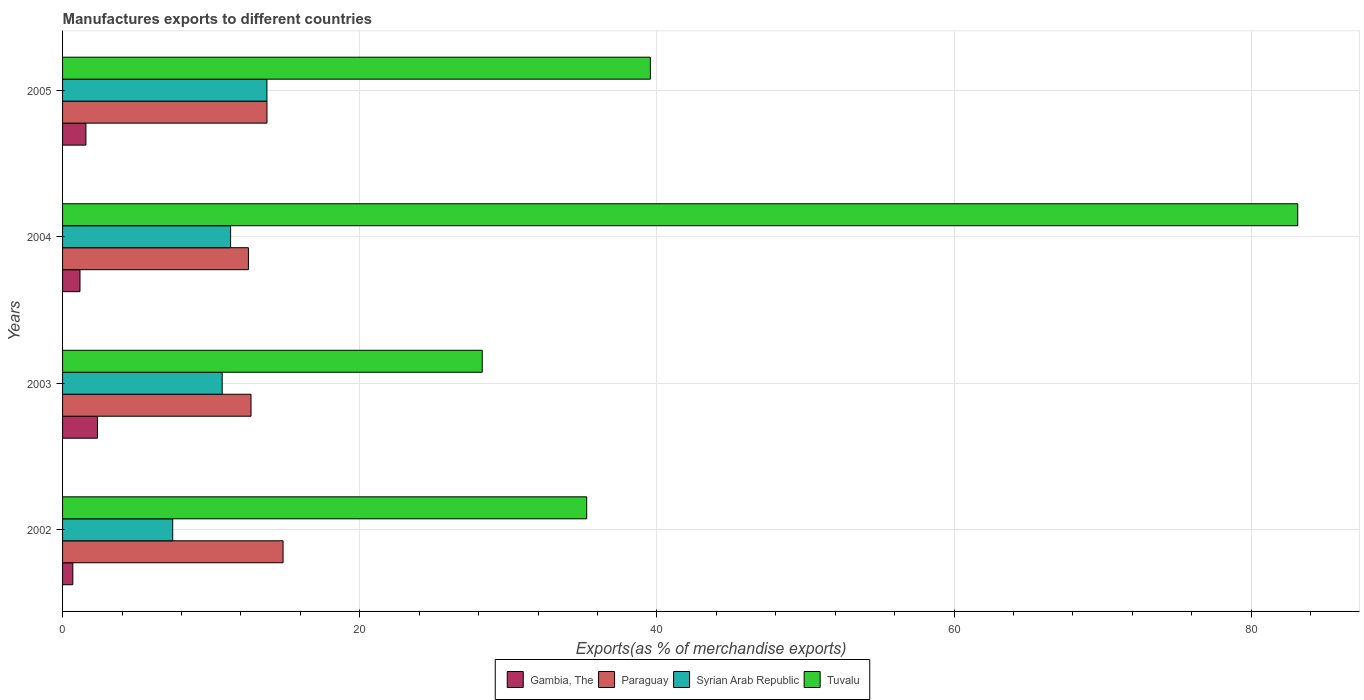How many groups of bars are there?
Your response must be concise. 4. Are the number of bars on each tick of the Y-axis equal?
Ensure brevity in your answer.  Yes. How many bars are there on the 4th tick from the top?
Your answer should be compact. 4. How many bars are there on the 3rd tick from the bottom?
Make the answer very short. 4. What is the label of the 3rd group of bars from the top?
Provide a succinct answer. 2003. What is the percentage of exports to different countries in Paraguay in 2004?
Keep it short and to the point. 12.51. Across all years, what is the maximum percentage of exports to different countries in Gambia, The?
Your answer should be compact. 2.35. Across all years, what is the minimum percentage of exports to different countries in Gambia, The?
Make the answer very short. 0.69. In which year was the percentage of exports to different countries in Syrian Arab Republic maximum?
Keep it short and to the point. 2005. What is the total percentage of exports to different countries in Paraguay in the graph?
Your response must be concise. 53.79. What is the difference between the percentage of exports to different countries in Tuvalu in 2003 and that in 2005?
Give a very brief answer. -11.32. What is the difference between the percentage of exports to different countries in Syrian Arab Republic in 2003 and the percentage of exports to different countries in Gambia, The in 2002?
Make the answer very short. 10.05. What is the average percentage of exports to different countries in Syrian Arab Republic per year?
Provide a short and direct response. 10.8. In the year 2003, what is the difference between the percentage of exports to different countries in Gambia, The and percentage of exports to different countries in Tuvalu?
Offer a very short reply. -25.9. In how many years, is the percentage of exports to different countries in Paraguay greater than 48 %?
Ensure brevity in your answer.  0. What is the ratio of the percentage of exports to different countries in Paraguay in 2004 to that in 2005?
Your answer should be very brief. 0.91. What is the difference between the highest and the second highest percentage of exports to different countries in Syrian Arab Republic?
Your response must be concise. 2.44. What is the difference between the highest and the lowest percentage of exports to different countries in Paraguay?
Provide a succinct answer. 2.33. In how many years, is the percentage of exports to different countries in Tuvalu greater than the average percentage of exports to different countries in Tuvalu taken over all years?
Your response must be concise. 1. Is the sum of the percentage of exports to different countries in Syrian Arab Republic in 2003 and 2004 greater than the maximum percentage of exports to different countries in Paraguay across all years?
Your response must be concise. Yes. What does the 2nd bar from the top in 2004 represents?
Offer a very short reply. Syrian Arab Republic. What does the 2nd bar from the bottom in 2002 represents?
Provide a short and direct response. Paraguay. How many bars are there?
Your response must be concise. 16. Does the graph contain any zero values?
Offer a terse response. No. Where does the legend appear in the graph?
Provide a succinct answer. Bottom center. How many legend labels are there?
Keep it short and to the point. 4. What is the title of the graph?
Your answer should be compact. Manufactures exports to different countries. Does "East Asia (all income levels)" appear as one of the legend labels in the graph?
Make the answer very short. No. What is the label or title of the X-axis?
Ensure brevity in your answer.  Exports(as % of merchandise exports). What is the label or title of the Y-axis?
Provide a succinct answer. Years. What is the Exports(as % of merchandise exports) in Gambia, The in 2002?
Provide a short and direct response. 0.69. What is the Exports(as % of merchandise exports) of Paraguay in 2002?
Offer a terse response. 14.84. What is the Exports(as % of merchandise exports) in Syrian Arab Republic in 2002?
Offer a very short reply. 7.41. What is the Exports(as % of merchandise exports) in Tuvalu in 2002?
Your answer should be very brief. 35.28. What is the Exports(as % of merchandise exports) of Gambia, The in 2003?
Offer a terse response. 2.35. What is the Exports(as % of merchandise exports) of Paraguay in 2003?
Your answer should be compact. 12.68. What is the Exports(as % of merchandise exports) in Syrian Arab Republic in 2003?
Offer a very short reply. 10.74. What is the Exports(as % of merchandise exports) in Tuvalu in 2003?
Your answer should be compact. 28.25. What is the Exports(as % of merchandise exports) in Gambia, The in 2004?
Ensure brevity in your answer.  1.17. What is the Exports(as % of merchandise exports) of Paraguay in 2004?
Offer a terse response. 12.51. What is the Exports(as % of merchandise exports) of Syrian Arab Republic in 2004?
Keep it short and to the point. 11.31. What is the Exports(as % of merchandise exports) in Tuvalu in 2004?
Make the answer very short. 83.13. What is the Exports(as % of merchandise exports) of Gambia, The in 2005?
Make the answer very short. 1.57. What is the Exports(as % of merchandise exports) of Paraguay in 2005?
Your answer should be very brief. 13.76. What is the Exports(as % of merchandise exports) in Syrian Arab Republic in 2005?
Your answer should be very brief. 13.75. What is the Exports(as % of merchandise exports) in Tuvalu in 2005?
Ensure brevity in your answer.  39.56. Across all years, what is the maximum Exports(as % of merchandise exports) in Gambia, The?
Offer a terse response. 2.35. Across all years, what is the maximum Exports(as % of merchandise exports) of Paraguay?
Give a very brief answer. 14.84. Across all years, what is the maximum Exports(as % of merchandise exports) in Syrian Arab Republic?
Your answer should be very brief. 13.75. Across all years, what is the maximum Exports(as % of merchandise exports) of Tuvalu?
Your answer should be compact. 83.13. Across all years, what is the minimum Exports(as % of merchandise exports) in Gambia, The?
Give a very brief answer. 0.69. Across all years, what is the minimum Exports(as % of merchandise exports) in Paraguay?
Offer a terse response. 12.51. Across all years, what is the minimum Exports(as % of merchandise exports) in Syrian Arab Republic?
Provide a succinct answer. 7.41. Across all years, what is the minimum Exports(as % of merchandise exports) of Tuvalu?
Provide a short and direct response. 28.25. What is the total Exports(as % of merchandise exports) of Gambia, The in the graph?
Make the answer very short. 5.79. What is the total Exports(as % of merchandise exports) in Paraguay in the graph?
Keep it short and to the point. 53.79. What is the total Exports(as % of merchandise exports) of Syrian Arab Republic in the graph?
Provide a succinct answer. 43.22. What is the total Exports(as % of merchandise exports) in Tuvalu in the graph?
Make the answer very short. 186.22. What is the difference between the Exports(as % of merchandise exports) in Gambia, The in 2002 and that in 2003?
Provide a succinct answer. -1.66. What is the difference between the Exports(as % of merchandise exports) in Paraguay in 2002 and that in 2003?
Offer a very short reply. 2.16. What is the difference between the Exports(as % of merchandise exports) in Syrian Arab Republic in 2002 and that in 2003?
Offer a terse response. -3.33. What is the difference between the Exports(as % of merchandise exports) in Tuvalu in 2002 and that in 2003?
Make the answer very short. 7.03. What is the difference between the Exports(as % of merchandise exports) of Gambia, The in 2002 and that in 2004?
Your answer should be very brief. -0.48. What is the difference between the Exports(as % of merchandise exports) of Paraguay in 2002 and that in 2004?
Your response must be concise. 2.33. What is the difference between the Exports(as % of merchandise exports) in Syrian Arab Republic in 2002 and that in 2004?
Provide a succinct answer. -3.9. What is the difference between the Exports(as % of merchandise exports) in Tuvalu in 2002 and that in 2004?
Provide a succinct answer. -47.86. What is the difference between the Exports(as % of merchandise exports) of Gambia, The in 2002 and that in 2005?
Your answer should be compact. -0.88. What is the difference between the Exports(as % of merchandise exports) in Paraguay in 2002 and that in 2005?
Offer a terse response. 1.08. What is the difference between the Exports(as % of merchandise exports) of Syrian Arab Republic in 2002 and that in 2005?
Give a very brief answer. -6.34. What is the difference between the Exports(as % of merchandise exports) in Tuvalu in 2002 and that in 2005?
Your response must be concise. -4.29. What is the difference between the Exports(as % of merchandise exports) of Gambia, The in 2003 and that in 2004?
Provide a short and direct response. 1.18. What is the difference between the Exports(as % of merchandise exports) of Paraguay in 2003 and that in 2004?
Give a very brief answer. 0.17. What is the difference between the Exports(as % of merchandise exports) of Syrian Arab Republic in 2003 and that in 2004?
Provide a short and direct response. -0.57. What is the difference between the Exports(as % of merchandise exports) of Tuvalu in 2003 and that in 2004?
Ensure brevity in your answer.  -54.89. What is the difference between the Exports(as % of merchandise exports) of Gambia, The in 2003 and that in 2005?
Your answer should be very brief. 0.78. What is the difference between the Exports(as % of merchandise exports) in Paraguay in 2003 and that in 2005?
Make the answer very short. -1.07. What is the difference between the Exports(as % of merchandise exports) in Syrian Arab Republic in 2003 and that in 2005?
Your answer should be very brief. -3.01. What is the difference between the Exports(as % of merchandise exports) in Tuvalu in 2003 and that in 2005?
Provide a short and direct response. -11.32. What is the difference between the Exports(as % of merchandise exports) in Gambia, The in 2004 and that in 2005?
Provide a short and direct response. -0.4. What is the difference between the Exports(as % of merchandise exports) of Paraguay in 2004 and that in 2005?
Make the answer very short. -1.25. What is the difference between the Exports(as % of merchandise exports) of Syrian Arab Republic in 2004 and that in 2005?
Your answer should be very brief. -2.44. What is the difference between the Exports(as % of merchandise exports) of Tuvalu in 2004 and that in 2005?
Make the answer very short. 43.57. What is the difference between the Exports(as % of merchandise exports) of Gambia, The in 2002 and the Exports(as % of merchandise exports) of Paraguay in 2003?
Provide a short and direct response. -11.99. What is the difference between the Exports(as % of merchandise exports) in Gambia, The in 2002 and the Exports(as % of merchandise exports) in Syrian Arab Republic in 2003?
Provide a succinct answer. -10.05. What is the difference between the Exports(as % of merchandise exports) of Gambia, The in 2002 and the Exports(as % of merchandise exports) of Tuvalu in 2003?
Your answer should be compact. -27.56. What is the difference between the Exports(as % of merchandise exports) of Paraguay in 2002 and the Exports(as % of merchandise exports) of Syrian Arab Republic in 2003?
Provide a succinct answer. 4.1. What is the difference between the Exports(as % of merchandise exports) of Paraguay in 2002 and the Exports(as % of merchandise exports) of Tuvalu in 2003?
Your response must be concise. -13.41. What is the difference between the Exports(as % of merchandise exports) in Syrian Arab Republic in 2002 and the Exports(as % of merchandise exports) in Tuvalu in 2003?
Give a very brief answer. -20.83. What is the difference between the Exports(as % of merchandise exports) of Gambia, The in 2002 and the Exports(as % of merchandise exports) of Paraguay in 2004?
Your answer should be very brief. -11.82. What is the difference between the Exports(as % of merchandise exports) of Gambia, The in 2002 and the Exports(as % of merchandise exports) of Syrian Arab Republic in 2004?
Give a very brief answer. -10.62. What is the difference between the Exports(as % of merchandise exports) in Gambia, The in 2002 and the Exports(as % of merchandise exports) in Tuvalu in 2004?
Provide a short and direct response. -82.44. What is the difference between the Exports(as % of merchandise exports) in Paraguay in 2002 and the Exports(as % of merchandise exports) in Syrian Arab Republic in 2004?
Offer a very short reply. 3.53. What is the difference between the Exports(as % of merchandise exports) in Paraguay in 2002 and the Exports(as % of merchandise exports) in Tuvalu in 2004?
Ensure brevity in your answer.  -68.29. What is the difference between the Exports(as % of merchandise exports) in Syrian Arab Republic in 2002 and the Exports(as % of merchandise exports) in Tuvalu in 2004?
Your response must be concise. -75.72. What is the difference between the Exports(as % of merchandise exports) of Gambia, The in 2002 and the Exports(as % of merchandise exports) of Paraguay in 2005?
Offer a terse response. -13.07. What is the difference between the Exports(as % of merchandise exports) in Gambia, The in 2002 and the Exports(as % of merchandise exports) in Syrian Arab Republic in 2005?
Offer a terse response. -13.06. What is the difference between the Exports(as % of merchandise exports) of Gambia, The in 2002 and the Exports(as % of merchandise exports) of Tuvalu in 2005?
Your answer should be compact. -38.87. What is the difference between the Exports(as % of merchandise exports) in Paraguay in 2002 and the Exports(as % of merchandise exports) in Syrian Arab Republic in 2005?
Give a very brief answer. 1.09. What is the difference between the Exports(as % of merchandise exports) of Paraguay in 2002 and the Exports(as % of merchandise exports) of Tuvalu in 2005?
Keep it short and to the point. -24.72. What is the difference between the Exports(as % of merchandise exports) in Syrian Arab Republic in 2002 and the Exports(as % of merchandise exports) in Tuvalu in 2005?
Give a very brief answer. -32.15. What is the difference between the Exports(as % of merchandise exports) of Gambia, The in 2003 and the Exports(as % of merchandise exports) of Paraguay in 2004?
Your answer should be compact. -10.16. What is the difference between the Exports(as % of merchandise exports) in Gambia, The in 2003 and the Exports(as % of merchandise exports) in Syrian Arab Republic in 2004?
Keep it short and to the point. -8.96. What is the difference between the Exports(as % of merchandise exports) of Gambia, The in 2003 and the Exports(as % of merchandise exports) of Tuvalu in 2004?
Provide a succinct answer. -80.78. What is the difference between the Exports(as % of merchandise exports) in Paraguay in 2003 and the Exports(as % of merchandise exports) in Syrian Arab Republic in 2004?
Offer a very short reply. 1.37. What is the difference between the Exports(as % of merchandise exports) in Paraguay in 2003 and the Exports(as % of merchandise exports) in Tuvalu in 2004?
Your response must be concise. -70.45. What is the difference between the Exports(as % of merchandise exports) in Syrian Arab Republic in 2003 and the Exports(as % of merchandise exports) in Tuvalu in 2004?
Provide a succinct answer. -72.39. What is the difference between the Exports(as % of merchandise exports) of Gambia, The in 2003 and the Exports(as % of merchandise exports) of Paraguay in 2005?
Offer a terse response. -11.41. What is the difference between the Exports(as % of merchandise exports) of Gambia, The in 2003 and the Exports(as % of merchandise exports) of Syrian Arab Republic in 2005?
Make the answer very short. -11.4. What is the difference between the Exports(as % of merchandise exports) of Gambia, The in 2003 and the Exports(as % of merchandise exports) of Tuvalu in 2005?
Offer a very short reply. -37.21. What is the difference between the Exports(as % of merchandise exports) of Paraguay in 2003 and the Exports(as % of merchandise exports) of Syrian Arab Republic in 2005?
Your response must be concise. -1.07. What is the difference between the Exports(as % of merchandise exports) in Paraguay in 2003 and the Exports(as % of merchandise exports) in Tuvalu in 2005?
Provide a short and direct response. -26.88. What is the difference between the Exports(as % of merchandise exports) in Syrian Arab Republic in 2003 and the Exports(as % of merchandise exports) in Tuvalu in 2005?
Offer a very short reply. -28.82. What is the difference between the Exports(as % of merchandise exports) in Gambia, The in 2004 and the Exports(as % of merchandise exports) in Paraguay in 2005?
Give a very brief answer. -12.58. What is the difference between the Exports(as % of merchandise exports) in Gambia, The in 2004 and the Exports(as % of merchandise exports) in Syrian Arab Republic in 2005?
Provide a short and direct response. -12.58. What is the difference between the Exports(as % of merchandise exports) in Gambia, The in 2004 and the Exports(as % of merchandise exports) in Tuvalu in 2005?
Offer a terse response. -38.39. What is the difference between the Exports(as % of merchandise exports) in Paraguay in 2004 and the Exports(as % of merchandise exports) in Syrian Arab Republic in 2005?
Make the answer very short. -1.24. What is the difference between the Exports(as % of merchandise exports) of Paraguay in 2004 and the Exports(as % of merchandise exports) of Tuvalu in 2005?
Your answer should be very brief. -27.05. What is the difference between the Exports(as % of merchandise exports) in Syrian Arab Republic in 2004 and the Exports(as % of merchandise exports) in Tuvalu in 2005?
Keep it short and to the point. -28.25. What is the average Exports(as % of merchandise exports) of Gambia, The per year?
Offer a very short reply. 1.45. What is the average Exports(as % of merchandise exports) of Paraguay per year?
Provide a succinct answer. 13.45. What is the average Exports(as % of merchandise exports) of Syrian Arab Republic per year?
Keep it short and to the point. 10.8. What is the average Exports(as % of merchandise exports) of Tuvalu per year?
Your response must be concise. 46.55. In the year 2002, what is the difference between the Exports(as % of merchandise exports) in Gambia, The and Exports(as % of merchandise exports) in Paraguay?
Your response must be concise. -14.15. In the year 2002, what is the difference between the Exports(as % of merchandise exports) in Gambia, The and Exports(as % of merchandise exports) in Syrian Arab Republic?
Offer a very short reply. -6.72. In the year 2002, what is the difference between the Exports(as % of merchandise exports) in Gambia, The and Exports(as % of merchandise exports) in Tuvalu?
Keep it short and to the point. -34.59. In the year 2002, what is the difference between the Exports(as % of merchandise exports) in Paraguay and Exports(as % of merchandise exports) in Syrian Arab Republic?
Keep it short and to the point. 7.43. In the year 2002, what is the difference between the Exports(as % of merchandise exports) in Paraguay and Exports(as % of merchandise exports) in Tuvalu?
Your response must be concise. -20.44. In the year 2002, what is the difference between the Exports(as % of merchandise exports) of Syrian Arab Republic and Exports(as % of merchandise exports) of Tuvalu?
Ensure brevity in your answer.  -27.86. In the year 2003, what is the difference between the Exports(as % of merchandise exports) in Gambia, The and Exports(as % of merchandise exports) in Paraguay?
Ensure brevity in your answer.  -10.33. In the year 2003, what is the difference between the Exports(as % of merchandise exports) of Gambia, The and Exports(as % of merchandise exports) of Syrian Arab Republic?
Your answer should be very brief. -8.39. In the year 2003, what is the difference between the Exports(as % of merchandise exports) in Gambia, The and Exports(as % of merchandise exports) in Tuvalu?
Ensure brevity in your answer.  -25.9. In the year 2003, what is the difference between the Exports(as % of merchandise exports) in Paraguay and Exports(as % of merchandise exports) in Syrian Arab Republic?
Provide a succinct answer. 1.94. In the year 2003, what is the difference between the Exports(as % of merchandise exports) of Paraguay and Exports(as % of merchandise exports) of Tuvalu?
Offer a terse response. -15.56. In the year 2003, what is the difference between the Exports(as % of merchandise exports) in Syrian Arab Republic and Exports(as % of merchandise exports) in Tuvalu?
Ensure brevity in your answer.  -17.5. In the year 2004, what is the difference between the Exports(as % of merchandise exports) of Gambia, The and Exports(as % of merchandise exports) of Paraguay?
Offer a terse response. -11.34. In the year 2004, what is the difference between the Exports(as % of merchandise exports) in Gambia, The and Exports(as % of merchandise exports) in Syrian Arab Republic?
Give a very brief answer. -10.14. In the year 2004, what is the difference between the Exports(as % of merchandise exports) of Gambia, The and Exports(as % of merchandise exports) of Tuvalu?
Keep it short and to the point. -81.96. In the year 2004, what is the difference between the Exports(as % of merchandise exports) in Paraguay and Exports(as % of merchandise exports) in Syrian Arab Republic?
Keep it short and to the point. 1.2. In the year 2004, what is the difference between the Exports(as % of merchandise exports) in Paraguay and Exports(as % of merchandise exports) in Tuvalu?
Ensure brevity in your answer.  -70.62. In the year 2004, what is the difference between the Exports(as % of merchandise exports) of Syrian Arab Republic and Exports(as % of merchandise exports) of Tuvalu?
Your response must be concise. -71.82. In the year 2005, what is the difference between the Exports(as % of merchandise exports) in Gambia, The and Exports(as % of merchandise exports) in Paraguay?
Provide a short and direct response. -12.19. In the year 2005, what is the difference between the Exports(as % of merchandise exports) of Gambia, The and Exports(as % of merchandise exports) of Syrian Arab Republic?
Your response must be concise. -12.18. In the year 2005, what is the difference between the Exports(as % of merchandise exports) of Gambia, The and Exports(as % of merchandise exports) of Tuvalu?
Offer a terse response. -37.99. In the year 2005, what is the difference between the Exports(as % of merchandise exports) of Paraguay and Exports(as % of merchandise exports) of Syrian Arab Republic?
Give a very brief answer. 0. In the year 2005, what is the difference between the Exports(as % of merchandise exports) of Paraguay and Exports(as % of merchandise exports) of Tuvalu?
Ensure brevity in your answer.  -25.8. In the year 2005, what is the difference between the Exports(as % of merchandise exports) in Syrian Arab Republic and Exports(as % of merchandise exports) in Tuvalu?
Offer a very short reply. -25.81. What is the ratio of the Exports(as % of merchandise exports) in Gambia, The in 2002 to that in 2003?
Your response must be concise. 0.29. What is the ratio of the Exports(as % of merchandise exports) of Paraguay in 2002 to that in 2003?
Make the answer very short. 1.17. What is the ratio of the Exports(as % of merchandise exports) in Syrian Arab Republic in 2002 to that in 2003?
Provide a succinct answer. 0.69. What is the ratio of the Exports(as % of merchandise exports) of Tuvalu in 2002 to that in 2003?
Your answer should be compact. 1.25. What is the ratio of the Exports(as % of merchandise exports) of Gambia, The in 2002 to that in 2004?
Ensure brevity in your answer.  0.59. What is the ratio of the Exports(as % of merchandise exports) of Paraguay in 2002 to that in 2004?
Offer a terse response. 1.19. What is the ratio of the Exports(as % of merchandise exports) in Syrian Arab Republic in 2002 to that in 2004?
Keep it short and to the point. 0.66. What is the ratio of the Exports(as % of merchandise exports) in Tuvalu in 2002 to that in 2004?
Offer a terse response. 0.42. What is the ratio of the Exports(as % of merchandise exports) in Gambia, The in 2002 to that in 2005?
Give a very brief answer. 0.44. What is the ratio of the Exports(as % of merchandise exports) in Paraguay in 2002 to that in 2005?
Offer a terse response. 1.08. What is the ratio of the Exports(as % of merchandise exports) of Syrian Arab Republic in 2002 to that in 2005?
Make the answer very short. 0.54. What is the ratio of the Exports(as % of merchandise exports) of Tuvalu in 2002 to that in 2005?
Ensure brevity in your answer.  0.89. What is the ratio of the Exports(as % of merchandise exports) in Gambia, The in 2003 to that in 2004?
Keep it short and to the point. 2. What is the ratio of the Exports(as % of merchandise exports) of Paraguay in 2003 to that in 2004?
Keep it short and to the point. 1.01. What is the ratio of the Exports(as % of merchandise exports) in Syrian Arab Republic in 2003 to that in 2004?
Provide a succinct answer. 0.95. What is the ratio of the Exports(as % of merchandise exports) of Tuvalu in 2003 to that in 2004?
Make the answer very short. 0.34. What is the ratio of the Exports(as % of merchandise exports) of Gambia, The in 2003 to that in 2005?
Ensure brevity in your answer.  1.49. What is the ratio of the Exports(as % of merchandise exports) in Paraguay in 2003 to that in 2005?
Your answer should be compact. 0.92. What is the ratio of the Exports(as % of merchandise exports) of Syrian Arab Republic in 2003 to that in 2005?
Ensure brevity in your answer.  0.78. What is the ratio of the Exports(as % of merchandise exports) in Tuvalu in 2003 to that in 2005?
Offer a very short reply. 0.71. What is the ratio of the Exports(as % of merchandise exports) in Gambia, The in 2004 to that in 2005?
Your answer should be very brief. 0.75. What is the ratio of the Exports(as % of merchandise exports) in Paraguay in 2004 to that in 2005?
Keep it short and to the point. 0.91. What is the ratio of the Exports(as % of merchandise exports) in Syrian Arab Republic in 2004 to that in 2005?
Make the answer very short. 0.82. What is the ratio of the Exports(as % of merchandise exports) in Tuvalu in 2004 to that in 2005?
Offer a very short reply. 2.1. What is the difference between the highest and the second highest Exports(as % of merchandise exports) in Gambia, The?
Make the answer very short. 0.78. What is the difference between the highest and the second highest Exports(as % of merchandise exports) of Paraguay?
Provide a short and direct response. 1.08. What is the difference between the highest and the second highest Exports(as % of merchandise exports) of Syrian Arab Republic?
Your response must be concise. 2.44. What is the difference between the highest and the second highest Exports(as % of merchandise exports) of Tuvalu?
Your answer should be very brief. 43.57. What is the difference between the highest and the lowest Exports(as % of merchandise exports) in Gambia, The?
Offer a very short reply. 1.66. What is the difference between the highest and the lowest Exports(as % of merchandise exports) of Paraguay?
Offer a terse response. 2.33. What is the difference between the highest and the lowest Exports(as % of merchandise exports) in Syrian Arab Republic?
Keep it short and to the point. 6.34. What is the difference between the highest and the lowest Exports(as % of merchandise exports) in Tuvalu?
Offer a terse response. 54.89. 